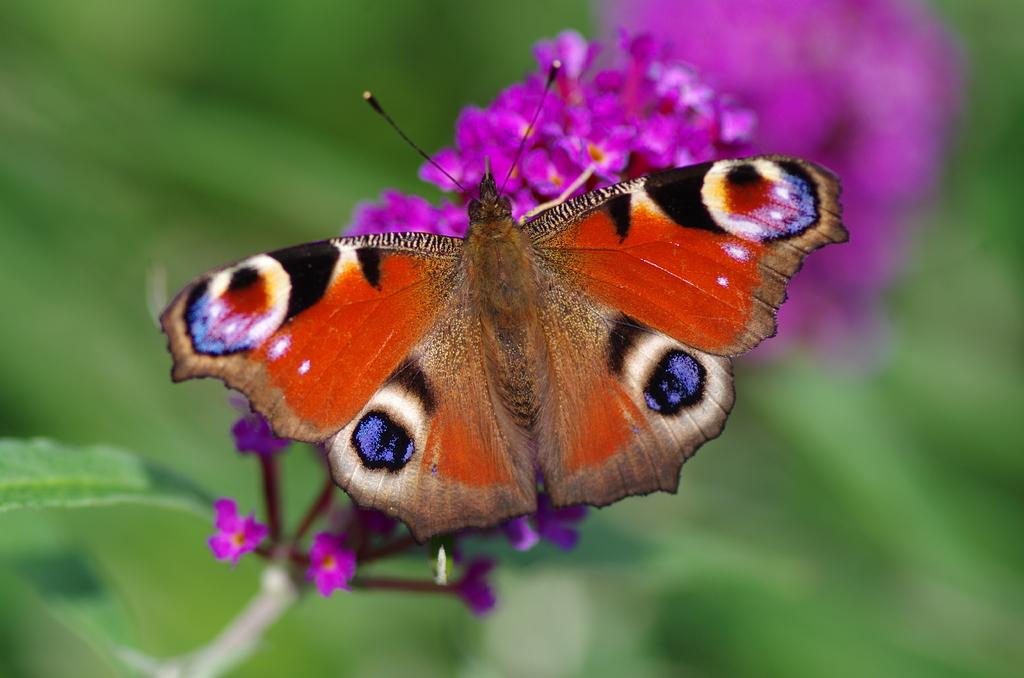What is one of the main subjects in the image? There is a flower in the image. What other living creature can be seen in the image? There is a butterfly in the image. Can you describe the background of the image? The background of the image is blurred. What type of quince is being cared for by the person in the image? There is no person or quince present in the image; it features a flower and a butterfly. 